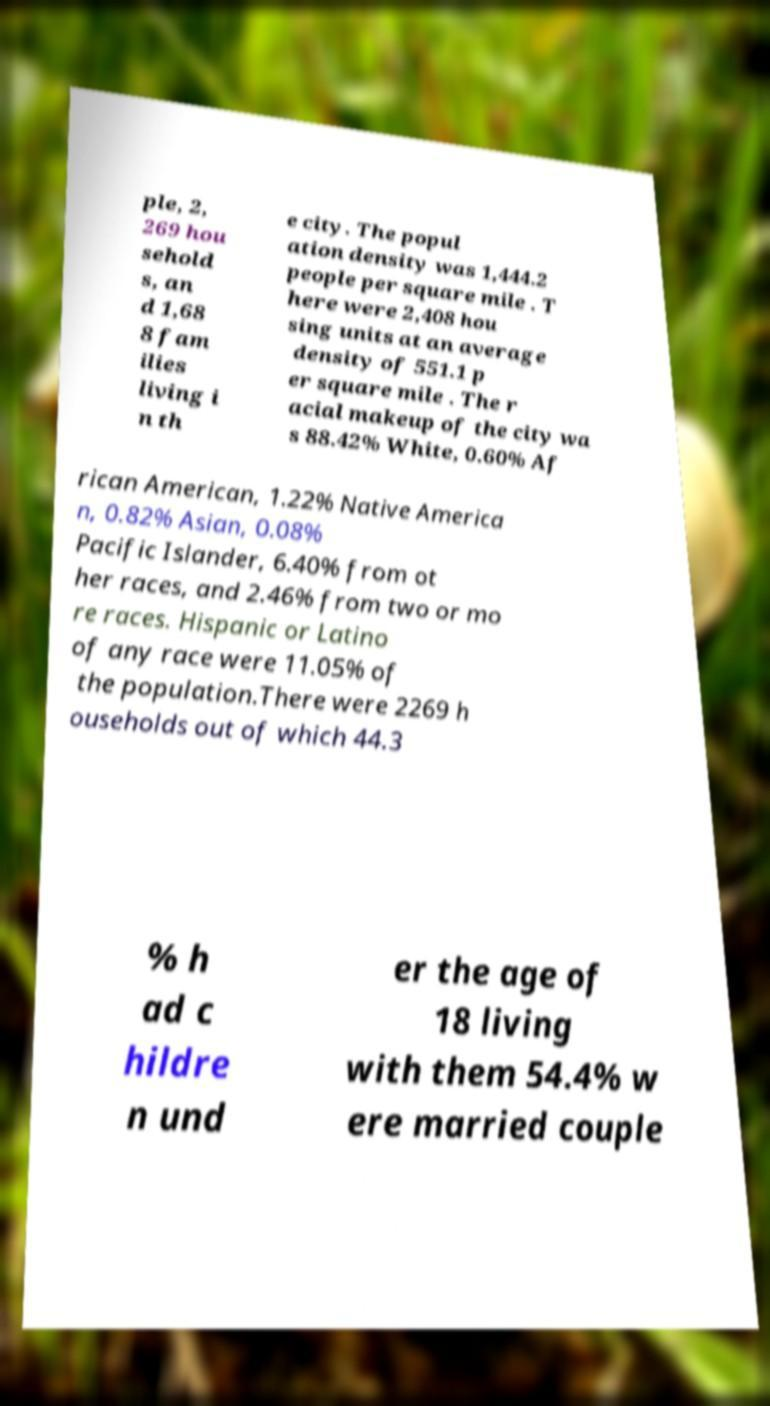I need the written content from this picture converted into text. Can you do that? ple, 2, 269 hou sehold s, an d 1,68 8 fam ilies living i n th e city. The popul ation density was 1,444.2 people per square mile . T here were 2,408 hou sing units at an average density of 551.1 p er square mile . The r acial makeup of the city wa s 88.42% White, 0.60% Af rican American, 1.22% Native America n, 0.82% Asian, 0.08% Pacific Islander, 6.40% from ot her races, and 2.46% from two or mo re races. Hispanic or Latino of any race were 11.05% of the population.There were 2269 h ouseholds out of which 44.3 % h ad c hildre n und er the age of 18 living with them 54.4% w ere married couple 